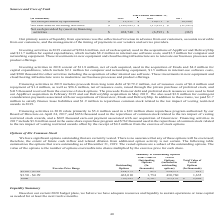From Zix Corporation's financial document, What was the amount used for capital expenditures in investing activities in 2018 and 2019? The document shows two values: 4.2 million and 11.7 million. From the document: "he acquisitions of AppRiver and DeliverySlip and $11.7 million for capital expenditures, which include $8.2 million in internal-use software costs, an..." Also, Which acquisitions made use of proceeds from the company's debt and preferred stock issuances in February 2019 and May 2019 respectively? The document shows two values: AppRiver and DeliverySlip. From the document: "net of cash acquired, used in the acquisitions of AppRiver and DeliverySlip and $11.7 million for capital expenditures, which include $8.2 million in ..." Also, What are the company's primary source of liquidity from operations? the collection of revenue in advance from our customers, accounts receivable from our customers, and the management of the timing of payments to our vendors and service providers.. The document states: "ur primary source of liquidity from operations was the collection of revenue in advance from our customers, accounts receivable from our customers, an..." Additionally, Which year had the highest Net cash provided by operations? According to the financial document, 2017. The relevant text states: "(In thousands) 2019 2018 2017..." Also, can you calculate: What is the percentage change in Net cash provided by operations from 2017 to 2018? To answer this question, I need to perform calculations using the financial data. The calculation is: (16,671-18,204)/18,204, which equals -8.42 (percentage). This is based on the information: "Net cash provided by operations $ 13,951 $ 16,671 $ 18,204 t cash provided by operations $ 13,951 $ 16,671 $ 18,204..." The key data points involved are: 16,671, 18,204. Also, For how many years was the Net cash used in financing activities more than $100,000? Based on the analysis, there are 1 instances. The counting process: 2019. 